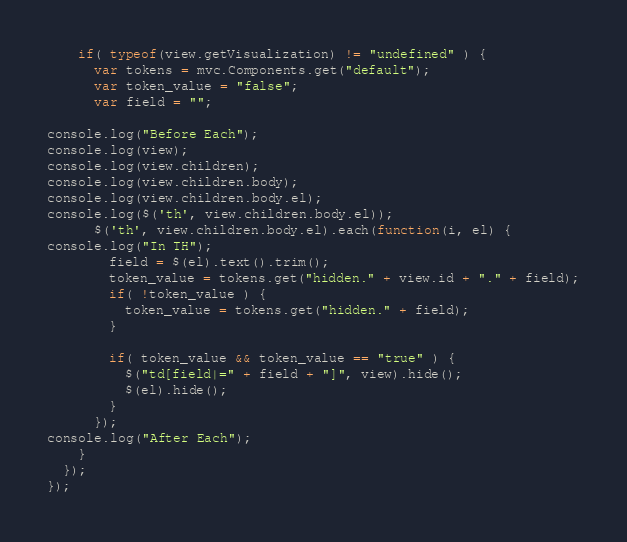Convert code to text. <code><loc_0><loc_0><loc_500><loc_500><_JavaScript_>    if( typeof(view.getVisualization) != "undefined" ) {
      var tokens = mvc.Components.get("default");
      var token_value = "false";
      var field = "";

console.log("Before Each");
console.log(view);
console.log(view.children);
console.log(view.children.body);
console.log(view.children.body.el);
console.log($('th', view.children.body.el));
      $('th', view.children.body.el).each(function(i, el) {
console.log("In TH");
        field = $(el).text().trim();
        token_value = tokens.get("hidden." + view.id + "." + field);
        if( !token_value ) {
          token_value = tokens.get("hidden." + field);
        }

        if( token_value && token_value == "true" ) {
          $("td[field|=" + field + "]", view).hide();
          $(el).hide();
        }
      });
console.log("After Each");
    }
  });
});
</code> 